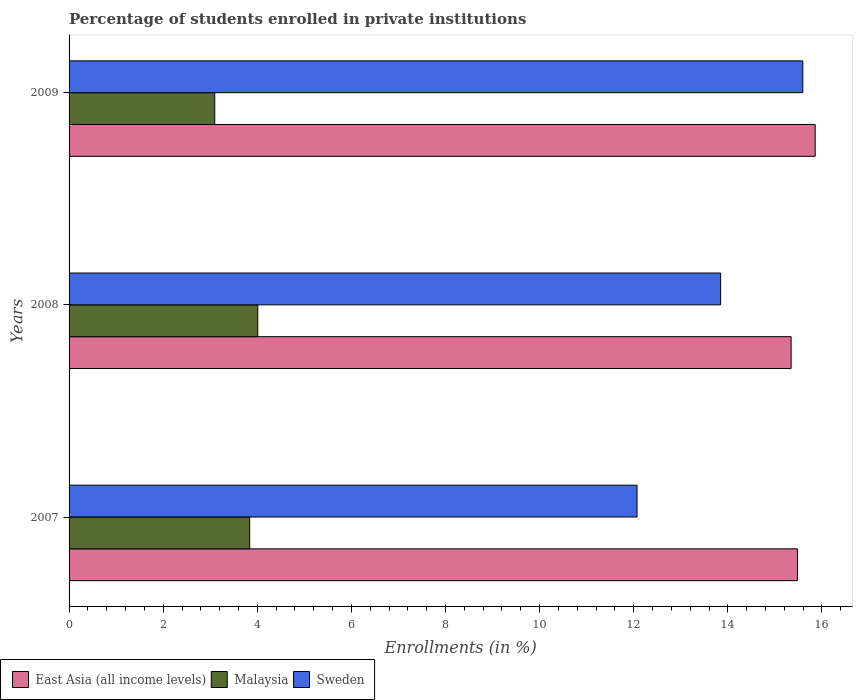How many different coloured bars are there?
Make the answer very short. 3. How many groups of bars are there?
Make the answer very short. 3. Are the number of bars per tick equal to the number of legend labels?
Provide a succinct answer. Yes. Are the number of bars on each tick of the Y-axis equal?
Provide a succinct answer. Yes. How many bars are there on the 2nd tick from the bottom?
Offer a terse response. 3. What is the percentage of trained teachers in East Asia (all income levels) in 2009?
Your response must be concise. 15.86. Across all years, what is the maximum percentage of trained teachers in Sweden?
Offer a terse response. 15.59. Across all years, what is the minimum percentage of trained teachers in Sweden?
Provide a short and direct response. 12.07. In which year was the percentage of trained teachers in Malaysia maximum?
Ensure brevity in your answer.  2008. What is the total percentage of trained teachers in East Asia (all income levels) in the graph?
Provide a short and direct response. 46.68. What is the difference between the percentage of trained teachers in East Asia (all income levels) in 2008 and that in 2009?
Provide a short and direct response. -0.51. What is the difference between the percentage of trained teachers in Malaysia in 2008 and the percentage of trained teachers in East Asia (all income levels) in 2007?
Provide a short and direct response. -11.47. What is the average percentage of trained teachers in East Asia (all income levels) per year?
Provide a short and direct response. 15.56. In the year 2009, what is the difference between the percentage of trained teachers in Sweden and percentage of trained teachers in Malaysia?
Your answer should be very brief. 12.5. What is the ratio of the percentage of trained teachers in Malaysia in 2007 to that in 2008?
Your answer should be compact. 0.96. Is the percentage of trained teachers in East Asia (all income levels) in 2008 less than that in 2009?
Provide a short and direct response. Yes. What is the difference between the highest and the second highest percentage of trained teachers in Malaysia?
Give a very brief answer. 0.17. What is the difference between the highest and the lowest percentage of trained teachers in East Asia (all income levels)?
Provide a short and direct response. 0.51. In how many years, is the percentage of trained teachers in East Asia (all income levels) greater than the average percentage of trained teachers in East Asia (all income levels) taken over all years?
Your response must be concise. 1. What does the 3rd bar from the top in 2008 represents?
Your answer should be compact. East Asia (all income levels). Is it the case that in every year, the sum of the percentage of trained teachers in Malaysia and percentage of trained teachers in East Asia (all income levels) is greater than the percentage of trained teachers in Sweden?
Offer a terse response. Yes. How many bars are there?
Provide a short and direct response. 9. Are all the bars in the graph horizontal?
Provide a short and direct response. Yes. How many years are there in the graph?
Make the answer very short. 3. Does the graph contain any zero values?
Your answer should be compact. No. Where does the legend appear in the graph?
Offer a terse response. Bottom left. How many legend labels are there?
Offer a terse response. 3. How are the legend labels stacked?
Your response must be concise. Horizontal. What is the title of the graph?
Ensure brevity in your answer.  Percentage of students enrolled in private institutions. Does "Uzbekistan" appear as one of the legend labels in the graph?
Offer a very short reply. No. What is the label or title of the X-axis?
Offer a terse response. Enrollments (in %). What is the label or title of the Y-axis?
Keep it short and to the point. Years. What is the Enrollments (in %) in East Asia (all income levels) in 2007?
Keep it short and to the point. 15.48. What is the Enrollments (in %) of Malaysia in 2007?
Make the answer very short. 3.84. What is the Enrollments (in %) in Sweden in 2007?
Offer a very short reply. 12.07. What is the Enrollments (in %) of East Asia (all income levels) in 2008?
Provide a succinct answer. 15.34. What is the Enrollments (in %) in Malaysia in 2008?
Your response must be concise. 4.01. What is the Enrollments (in %) of Sweden in 2008?
Give a very brief answer. 13.85. What is the Enrollments (in %) of East Asia (all income levels) in 2009?
Make the answer very short. 15.86. What is the Enrollments (in %) of Malaysia in 2009?
Your answer should be compact. 3.1. What is the Enrollments (in %) of Sweden in 2009?
Your answer should be compact. 15.59. Across all years, what is the maximum Enrollments (in %) in East Asia (all income levels)?
Your response must be concise. 15.86. Across all years, what is the maximum Enrollments (in %) of Malaysia?
Ensure brevity in your answer.  4.01. Across all years, what is the maximum Enrollments (in %) of Sweden?
Your answer should be compact. 15.59. Across all years, what is the minimum Enrollments (in %) in East Asia (all income levels)?
Keep it short and to the point. 15.34. Across all years, what is the minimum Enrollments (in %) in Malaysia?
Provide a short and direct response. 3.1. Across all years, what is the minimum Enrollments (in %) of Sweden?
Your response must be concise. 12.07. What is the total Enrollments (in %) in East Asia (all income levels) in the graph?
Your answer should be compact. 46.68. What is the total Enrollments (in %) in Malaysia in the graph?
Offer a terse response. 10.94. What is the total Enrollments (in %) in Sweden in the graph?
Ensure brevity in your answer.  41.51. What is the difference between the Enrollments (in %) of East Asia (all income levels) in 2007 and that in 2008?
Keep it short and to the point. 0.13. What is the difference between the Enrollments (in %) of Malaysia in 2007 and that in 2008?
Provide a short and direct response. -0.17. What is the difference between the Enrollments (in %) of Sweden in 2007 and that in 2008?
Make the answer very short. -1.78. What is the difference between the Enrollments (in %) in East Asia (all income levels) in 2007 and that in 2009?
Your answer should be very brief. -0.38. What is the difference between the Enrollments (in %) of Malaysia in 2007 and that in 2009?
Provide a short and direct response. 0.74. What is the difference between the Enrollments (in %) of Sweden in 2007 and that in 2009?
Make the answer very short. -3.52. What is the difference between the Enrollments (in %) of East Asia (all income levels) in 2008 and that in 2009?
Give a very brief answer. -0.51. What is the difference between the Enrollments (in %) of Malaysia in 2008 and that in 2009?
Your response must be concise. 0.91. What is the difference between the Enrollments (in %) in Sweden in 2008 and that in 2009?
Offer a very short reply. -1.75. What is the difference between the Enrollments (in %) in East Asia (all income levels) in 2007 and the Enrollments (in %) in Malaysia in 2008?
Your response must be concise. 11.47. What is the difference between the Enrollments (in %) in East Asia (all income levels) in 2007 and the Enrollments (in %) in Sweden in 2008?
Provide a short and direct response. 1.63. What is the difference between the Enrollments (in %) in Malaysia in 2007 and the Enrollments (in %) in Sweden in 2008?
Offer a very short reply. -10.01. What is the difference between the Enrollments (in %) of East Asia (all income levels) in 2007 and the Enrollments (in %) of Malaysia in 2009?
Keep it short and to the point. 12.38. What is the difference between the Enrollments (in %) in East Asia (all income levels) in 2007 and the Enrollments (in %) in Sweden in 2009?
Provide a succinct answer. -0.11. What is the difference between the Enrollments (in %) in Malaysia in 2007 and the Enrollments (in %) in Sweden in 2009?
Your answer should be compact. -11.75. What is the difference between the Enrollments (in %) in East Asia (all income levels) in 2008 and the Enrollments (in %) in Malaysia in 2009?
Make the answer very short. 12.25. What is the difference between the Enrollments (in %) in East Asia (all income levels) in 2008 and the Enrollments (in %) in Sweden in 2009?
Your answer should be compact. -0.25. What is the difference between the Enrollments (in %) in Malaysia in 2008 and the Enrollments (in %) in Sweden in 2009?
Provide a short and direct response. -11.58. What is the average Enrollments (in %) of East Asia (all income levels) per year?
Ensure brevity in your answer.  15.56. What is the average Enrollments (in %) in Malaysia per year?
Offer a terse response. 3.65. What is the average Enrollments (in %) of Sweden per year?
Keep it short and to the point. 13.84. In the year 2007, what is the difference between the Enrollments (in %) of East Asia (all income levels) and Enrollments (in %) of Malaysia?
Provide a succinct answer. 11.64. In the year 2007, what is the difference between the Enrollments (in %) in East Asia (all income levels) and Enrollments (in %) in Sweden?
Keep it short and to the point. 3.41. In the year 2007, what is the difference between the Enrollments (in %) in Malaysia and Enrollments (in %) in Sweden?
Your response must be concise. -8.23. In the year 2008, what is the difference between the Enrollments (in %) of East Asia (all income levels) and Enrollments (in %) of Malaysia?
Your answer should be compact. 11.33. In the year 2008, what is the difference between the Enrollments (in %) of East Asia (all income levels) and Enrollments (in %) of Sweden?
Your answer should be very brief. 1.5. In the year 2008, what is the difference between the Enrollments (in %) in Malaysia and Enrollments (in %) in Sweden?
Keep it short and to the point. -9.84. In the year 2009, what is the difference between the Enrollments (in %) of East Asia (all income levels) and Enrollments (in %) of Malaysia?
Provide a short and direct response. 12.76. In the year 2009, what is the difference between the Enrollments (in %) of East Asia (all income levels) and Enrollments (in %) of Sweden?
Provide a short and direct response. 0.26. In the year 2009, what is the difference between the Enrollments (in %) in Malaysia and Enrollments (in %) in Sweden?
Keep it short and to the point. -12.5. What is the ratio of the Enrollments (in %) of East Asia (all income levels) in 2007 to that in 2008?
Make the answer very short. 1.01. What is the ratio of the Enrollments (in %) of Malaysia in 2007 to that in 2008?
Give a very brief answer. 0.96. What is the ratio of the Enrollments (in %) in Sweden in 2007 to that in 2008?
Offer a very short reply. 0.87. What is the ratio of the Enrollments (in %) of East Asia (all income levels) in 2007 to that in 2009?
Provide a succinct answer. 0.98. What is the ratio of the Enrollments (in %) of Malaysia in 2007 to that in 2009?
Ensure brevity in your answer.  1.24. What is the ratio of the Enrollments (in %) in Sweden in 2007 to that in 2009?
Your answer should be compact. 0.77. What is the ratio of the Enrollments (in %) of East Asia (all income levels) in 2008 to that in 2009?
Provide a succinct answer. 0.97. What is the ratio of the Enrollments (in %) in Malaysia in 2008 to that in 2009?
Keep it short and to the point. 1.3. What is the ratio of the Enrollments (in %) of Sweden in 2008 to that in 2009?
Ensure brevity in your answer.  0.89. What is the difference between the highest and the second highest Enrollments (in %) of East Asia (all income levels)?
Offer a terse response. 0.38. What is the difference between the highest and the second highest Enrollments (in %) in Malaysia?
Give a very brief answer. 0.17. What is the difference between the highest and the second highest Enrollments (in %) of Sweden?
Offer a very short reply. 1.75. What is the difference between the highest and the lowest Enrollments (in %) of East Asia (all income levels)?
Offer a terse response. 0.51. What is the difference between the highest and the lowest Enrollments (in %) of Malaysia?
Your answer should be very brief. 0.91. What is the difference between the highest and the lowest Enrollments (in %) in Sweden?
Provide a short and direct response. 3.52. 